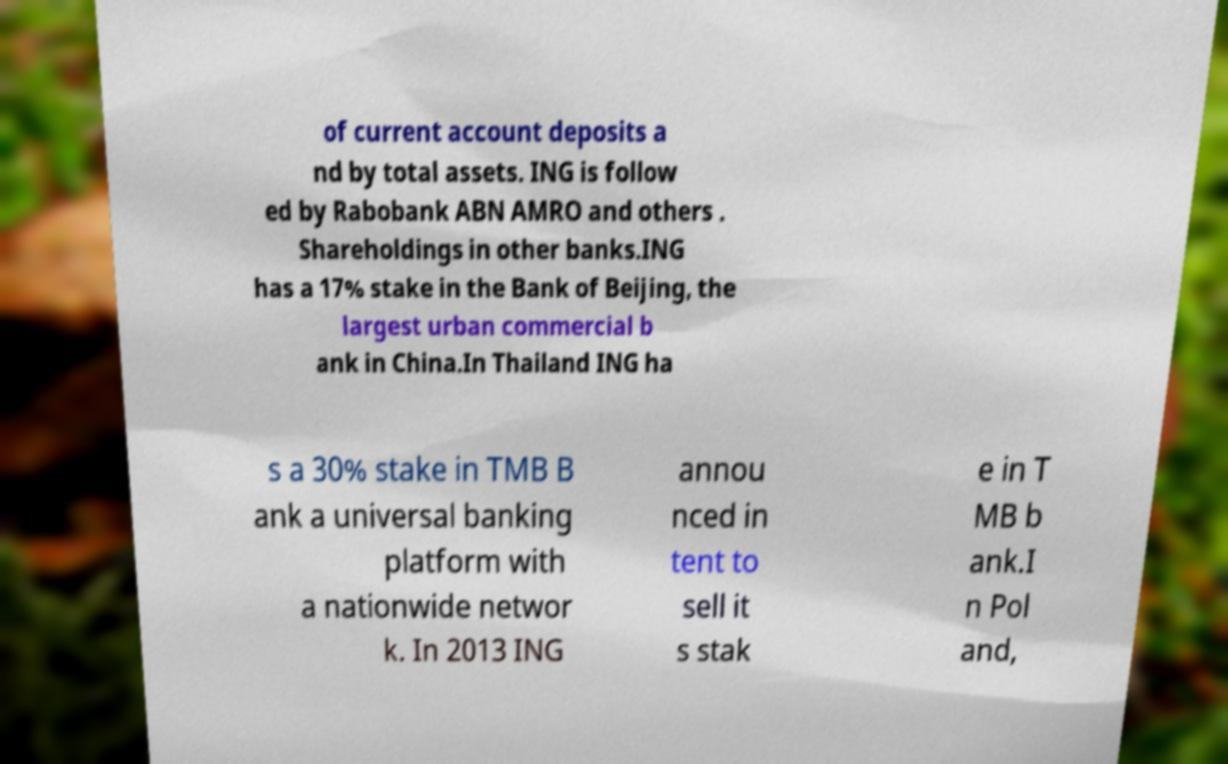Please read and relay the text visible in this image. What does it say? of current account deposits a nd by total assets. ING is follow ed by Rabobank ABN AMRO and others . Shareholdings in other banks.ING has a 17% stake in the Bank of Beijing, the largest urban commercial b ank in China.In Thailand ING ha s a 30% stake in TMB B ank a universal banking platform with a nationwide networ k. In 2013 ING annou nced in tent to sell it s stak e in T MB b ank.I n Pol and, 